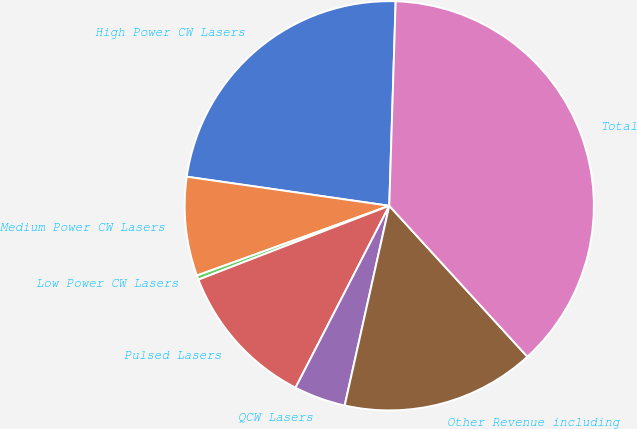Convert chart. <chart><loc_0><loc_0><loc_500><loc_500><pie_chart><fcel>High Power CW Lasers<fcel>Medium Power CW Lasers<fcel>Low Power CW Lasers<fcel>Pulsed Lasers<fcel>QCW Lasers<fcel>Other Revenue including<fcel>Total<nl><fcel>23.23%<fcel>7.81%<fcel>0.34%<fcel>11.55%<fcel>4.08%<fcel>15.29%<fcel>37.71%<nl></chart> 